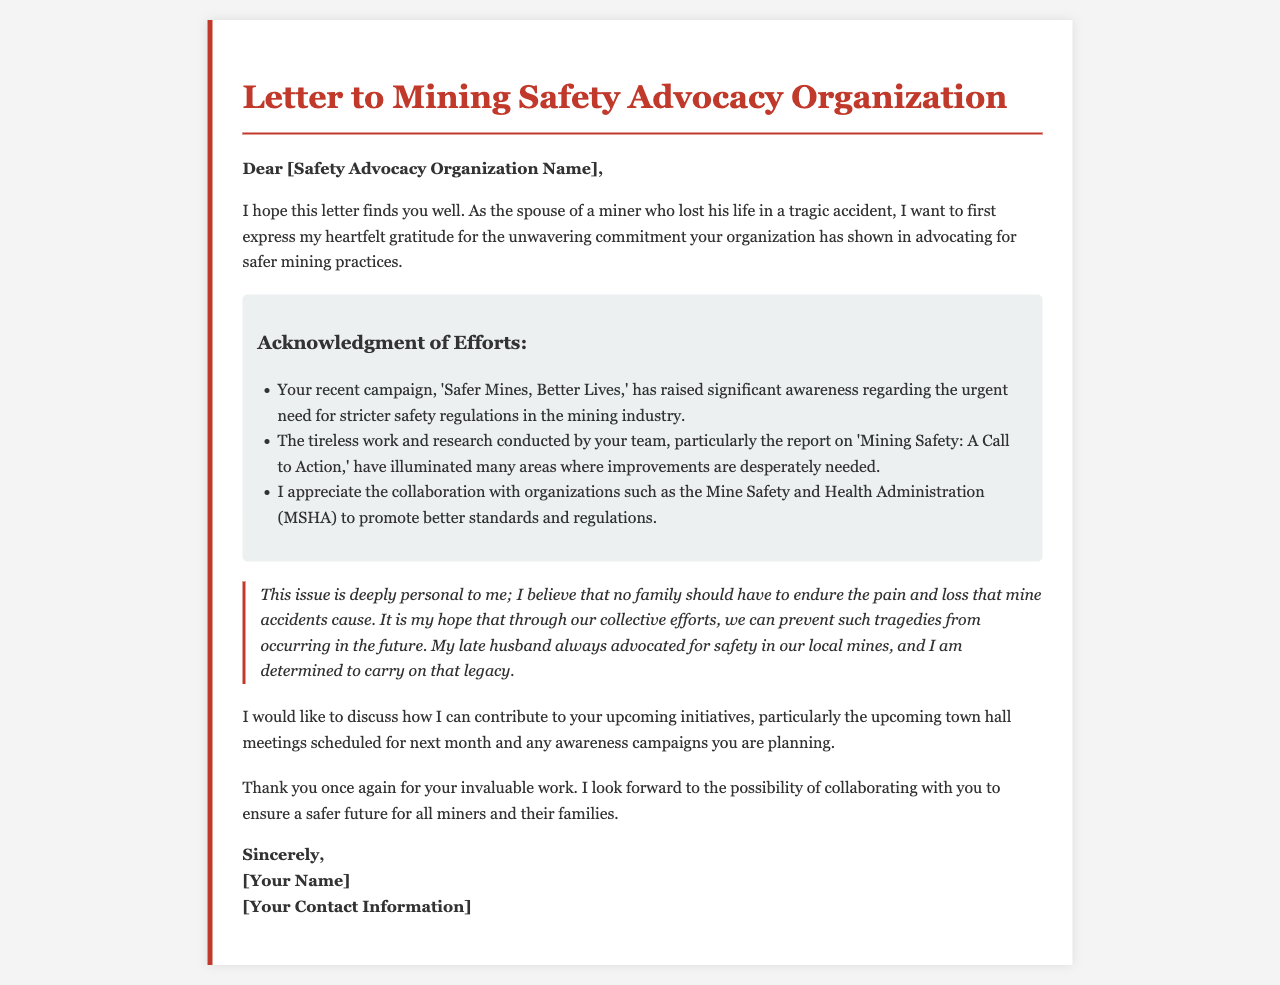What is the name of the campaign mentioned in the letter? The letter refers to the campaign 'Safer Mines, Better Lives.'
Answer: Safer Mines, Better Lives Who is the author of the letter? The letter does not provide a specific name for the author, but it refers to the author as the spouse of a miner.
Answer: [Your Name] What organization does the author appreciate collaborating with? The author appreciates collaboration with the Mine Safety and Health Administration (MSHA).
Answer: Mine Safety and Health Administration (MSHA) What does the author hope to discuss with the advocacy organization? The author wants to discuss how they can contribute to upcoming initiatives.
Answer: Upcoming initiatives What is the primary emotional motive behind the letter? The author expresses a personal loss and desire to prevent future tragedies in mining.
Answer: Prevent future tragedies What is the background color of the body in the letter? The background color of the body is light grey, as described in the document's styling.
Answer: #f4f4f4 What type of letter is this? The letter is a heartfelt letter expressing gratitude and requesting collaboration.
Answer: Heartfelt letter What is the primary focus of the advocacy organization according to the letter? The primary focus is advocating for safer mining practices.
Answer: Safer mining practices What is the tone of the letter? The tone of the letter is grateful and hopeful regarding future safety initiatives.
Answer: Grateful and hopeful 